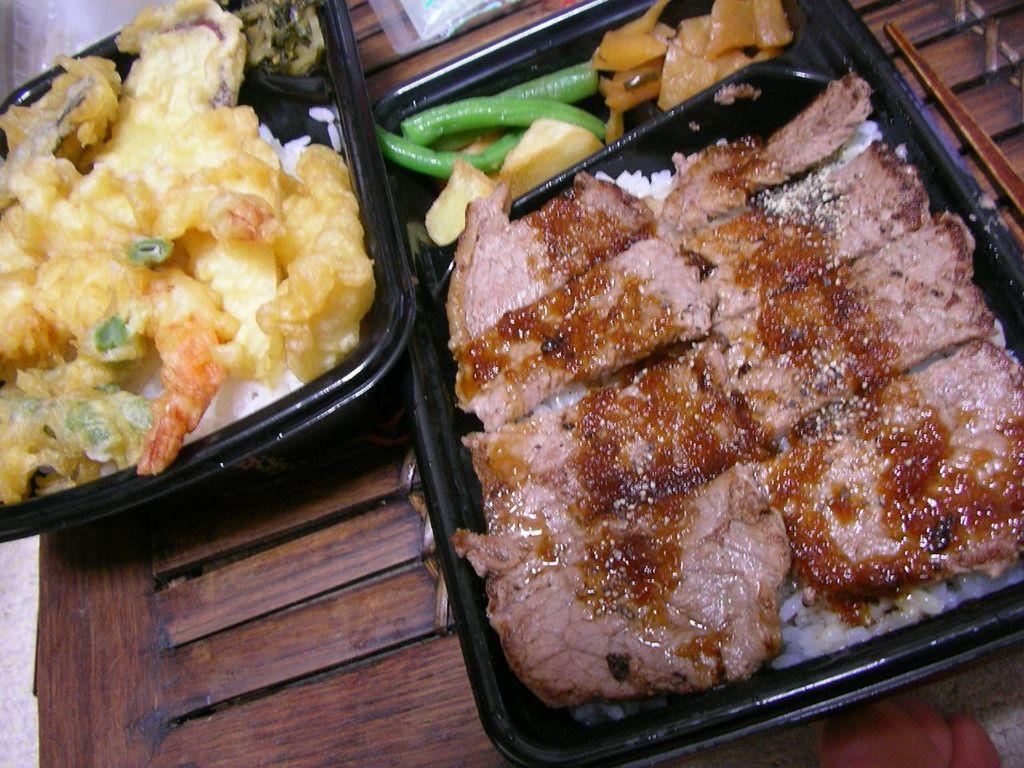Can you describe this image briefly? There are plastic boxes in the foreground area of the image, which contains food items placed on a wooden surface. 